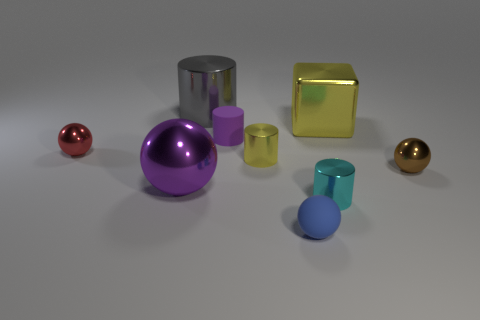Is there anything else that has the same color as the block?
Offer a very short reply. Yes. There is a shiny object that is behind the tiny yellow metal thing and on the right side of the large metallic cylinder; what is its color?
Provide a short and direct response. Yellow. There is a blue matte object that is to the right of the purple matte cylinder; is its size the same as the large gray object?
Provide a short and direct response. No. Is the number of metal objects to the right of the tiny blue ball greater than the number of tiny yellow metallic cylinders?
Your answer should be compact. Yes. Do the tiny cyan object and the gray shiny object have the same shape?
Your answer should be very brief. Yes. How big is the cyan cylinder?
Ensure brevity in your answer.  Small. Is the number of cylinders that are in front of the gray metallic thing greater than the number of small balls right of the small cyan metal thing?
Provide a short and direct response. Yes. Are there any balls to the right of the large shiny sphere?
Keep it short and to the point. Yes. Are there any brown things of the same size as the blue thing?
Your answer should be very brief. Yes. The big block that is made of the same material as the brown thing is what color?
Your answer should be very brief. Yellow. 